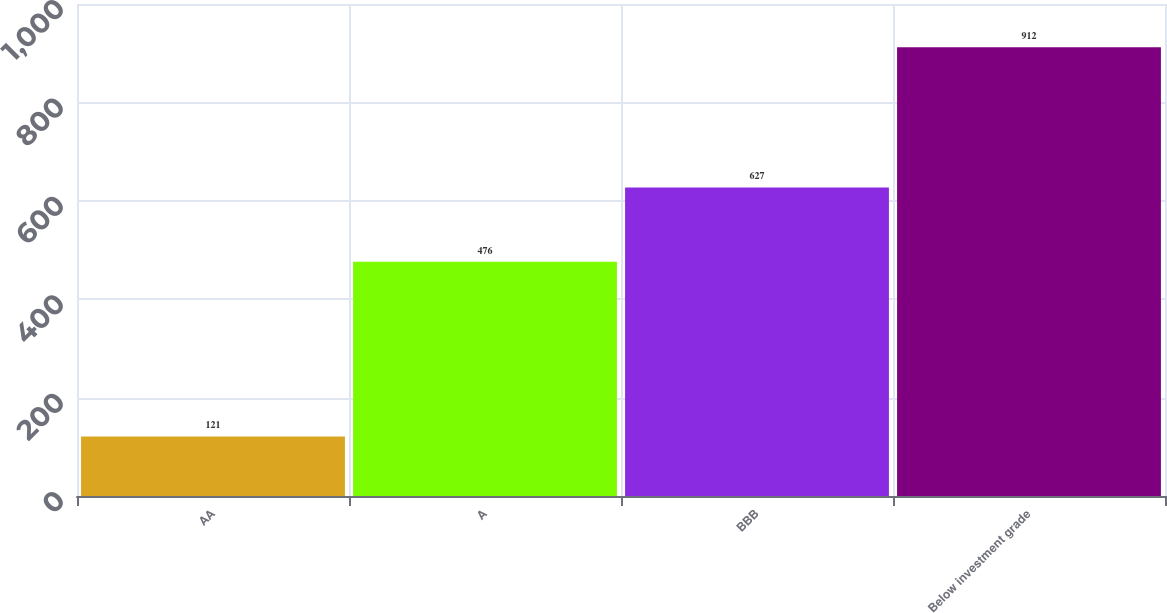<chart> <loc_0><loc_0><loc_500><loc_500><bar_chart><fcel>AA<fcel>A<fcel>BBB<fcel>Below investment grade<nl><fcel>121<fcel>476<fcel>627<fcel>912<nl></chart> 